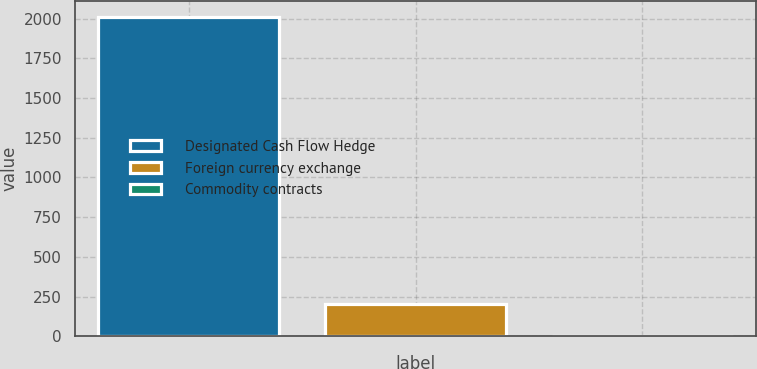Convert chart. <chart><loc_0><loc_0><loc_500><loc_500><bar_chart><fcel>Designated Cash Flow Hedge<fcel>Foreign currency exchange<fcel>Commodity contracts<nl><fcel>2009<fcel>201.8<fcel>1<nl></chart> 